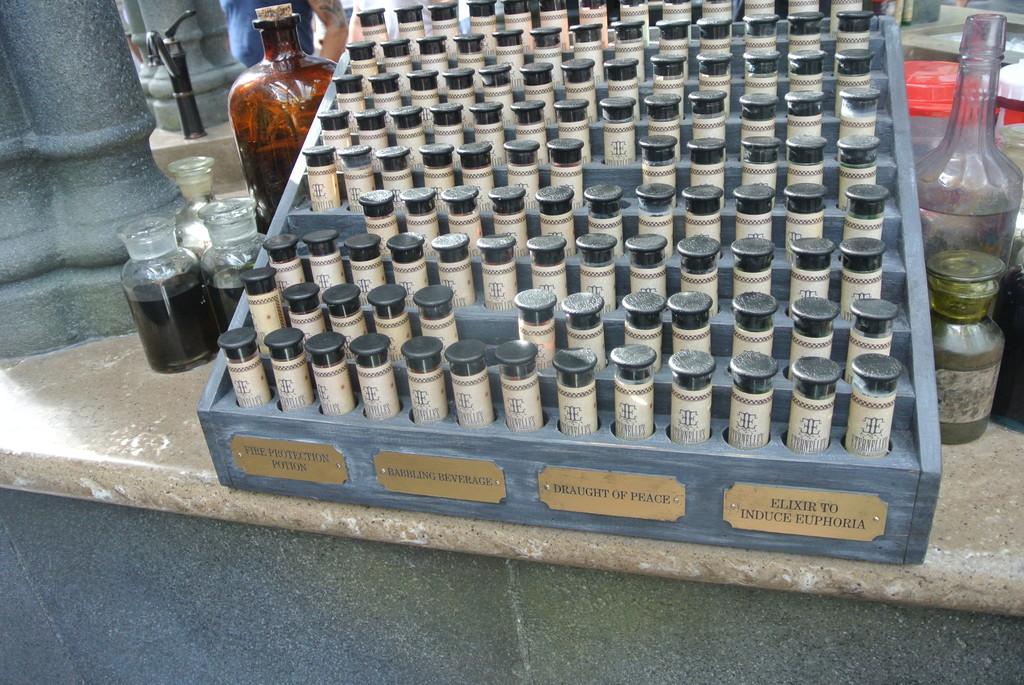Is there a draught of peace?
Your answer should be compact. Yes. 